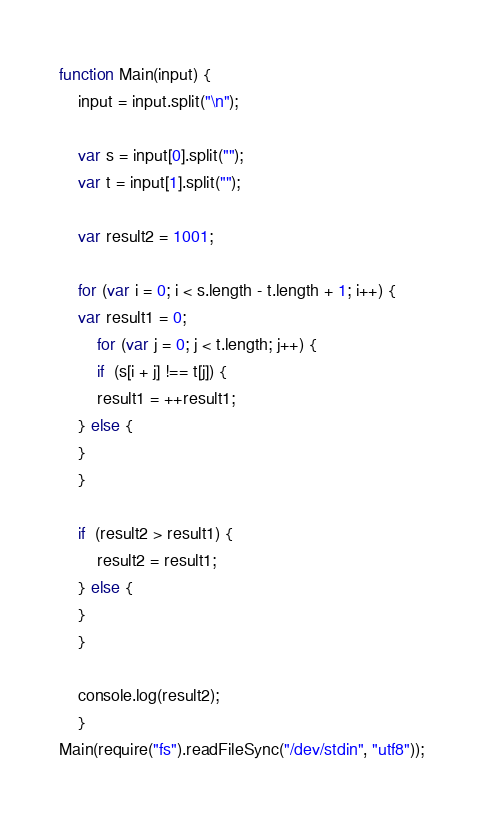<code> <loc_0><loc_0><loc_500><loc_500><_JavaScript_>function Main(input) {
	input = input.split("\n");
	
	var s = input[0].split("");
	var t = input[1].split("");
	
	var result2 = 1001;
	
	for (var i = 0; i < s.length - t.length + 1; i++) {
	var result1 = 0;
		for (var j = 0; j < t.length; j++) {
		if  (s[i + j] !== t[j]) {
		result1 = ++result1;
	} else {
	}
	}
	
	if  (result2 > result1) {
		result2 = result1;
	} else {
	}
	}
	
	console.log(result2);
	}
Main(require("fs").readFileSync("/dev/stdin", "utf8"));</code> 